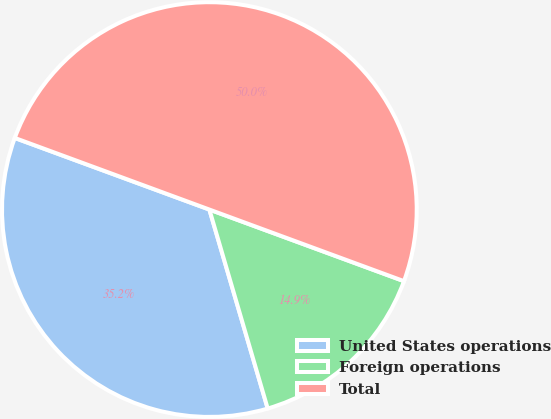Convert chart. <chart><loc_0><loc_0><loc_500><loc_500><pie_chart><fcel>United States operations<fcel>Foreign operations<fcel>Total<nl><fcel>35.15%<fcel>14.85%<fcel>50.0%<nl></chart> 